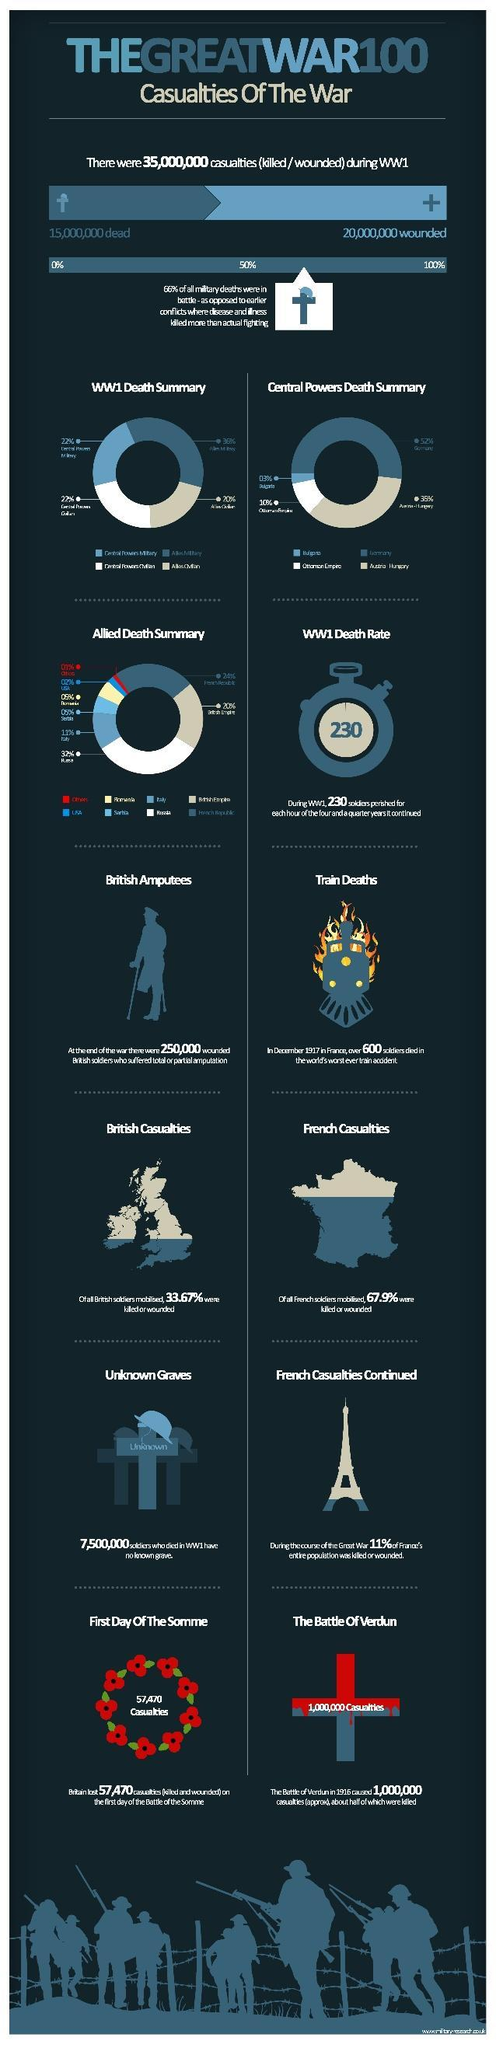How many people were injured in the Great War 100?
Answer the question with a short phrase. 20,000,000 What is the inverse percentage of the people from Britain who were injured or lost their lives in the great war 100? 66.33 How many soldiers from France were injured or lost their lives in the great war 100? 67.9% How many people died in the Great War 100? 15,000,000 